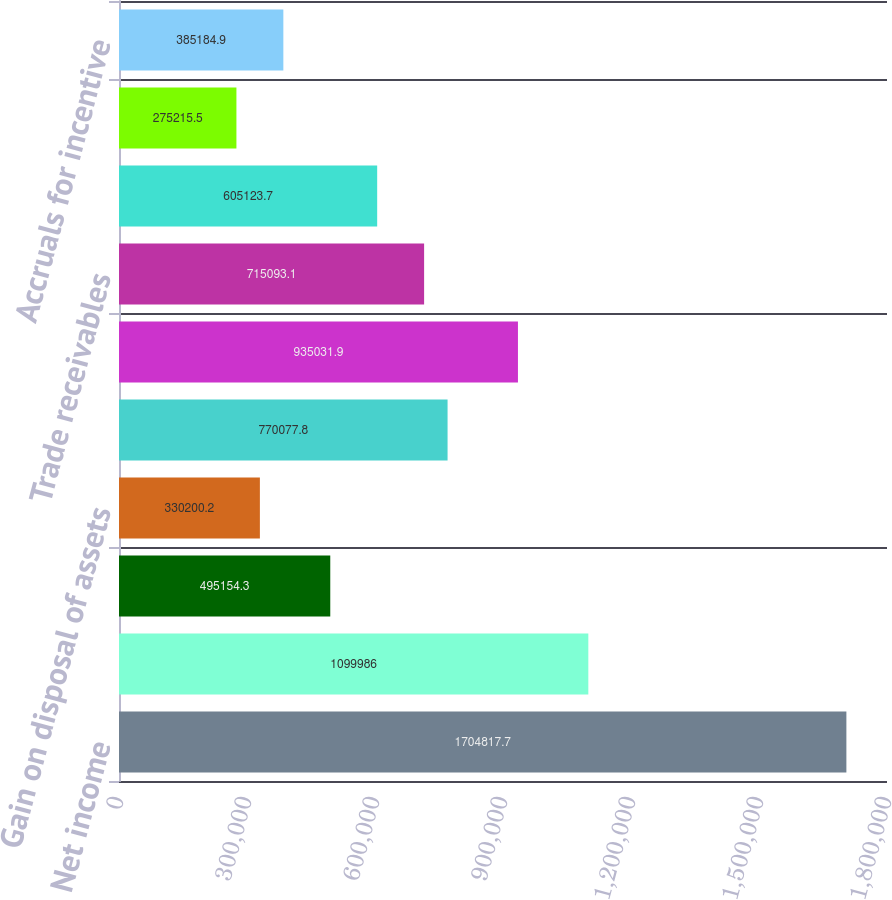Convert chart. <chart><loc_0><loc_0><loc_500><loc_500><bar_chart><fcel>Net income<fcel>Depreciation and amortization<fcel>Deferred income taxes<fcel>Gain on disposal of assets<fcel>Stock-based compensation<fcel>Pension contributions<fcel>Trade receivables<fcel>Inventories<fcel>Accounts payable<fcel>Accruals for incentive<nl><fcel>1.70482e+06<fcel>1.09999e+06<fcel>495154<fcel>330200<fcel>770078<fcel>935032<fcel>715093<fcel>605124<fcel>275216<fcel>385185<nl></chart> 